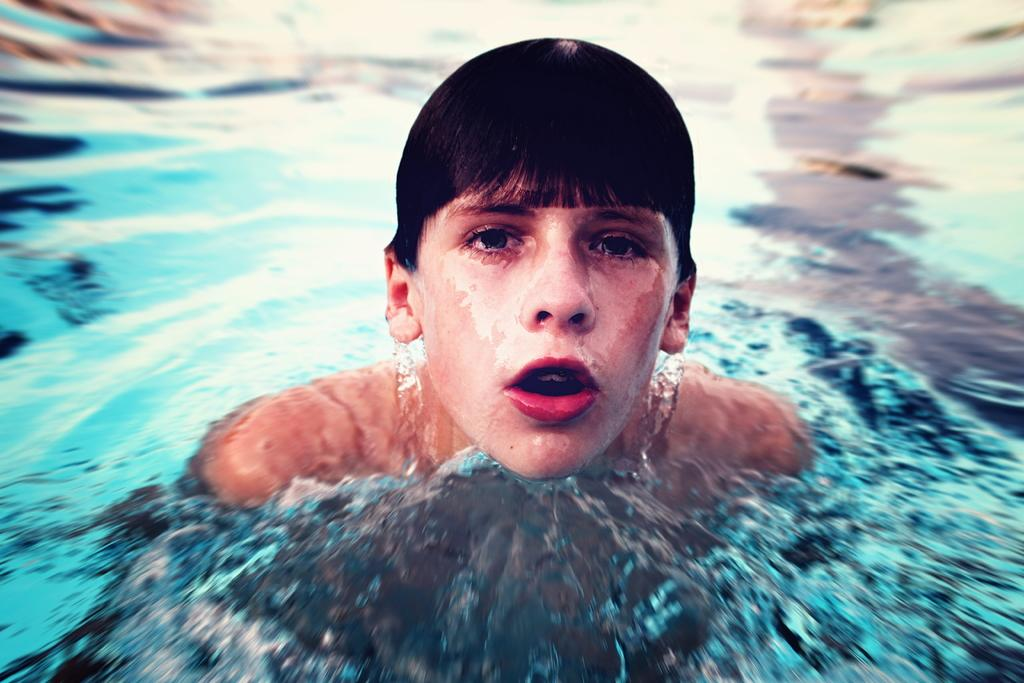Who is the main subject in the image? There is a boy in the image. What is the boy doing in the image? The boy is swimming. What is the primary element in which the boy is engaged in the image? There is water visible in the image. What type of scarecrow can be seen floating in the water in the image? There is no scarecrow present in the image; it features a boy swimming in the water. 